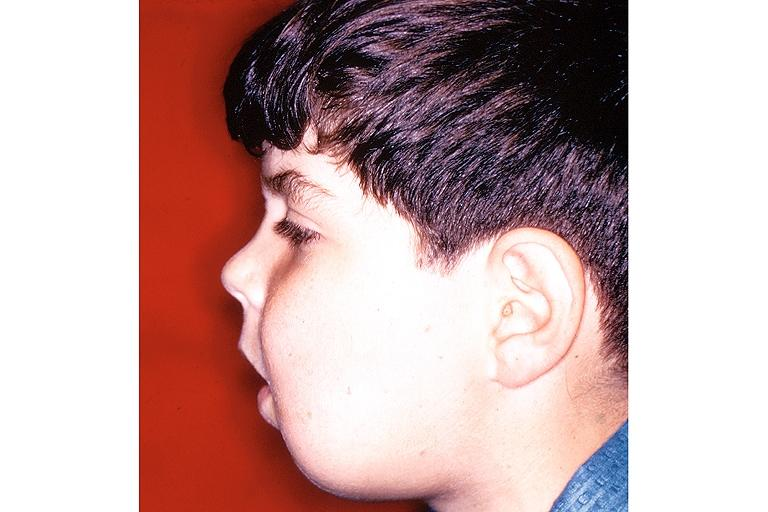what does this image show?
Answer the question using a single word or phrase. Cherubism 